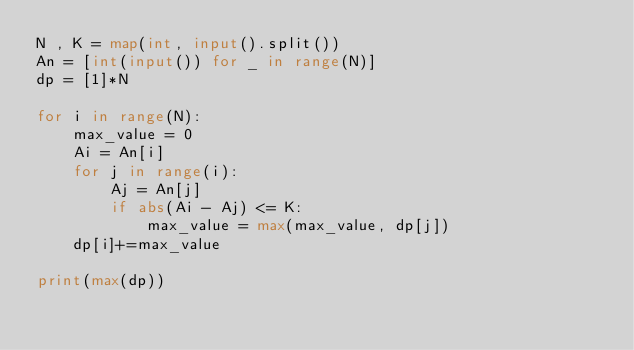Convert code to text. <code><loc_0><loc_0><loc_500><loc_500><_Python_>N , K = map(int, input().split())
An = [int(input()) for _ in range(N)]
dp = [1]*N

for i in range(N):
    max_value = 0
    Ai = An[i]
    for j in range(i):
        Aj = An[j]
        if abs(Ai - Aj) <= K:
            max_value = max(max_value, dp[j])
    dp[i]+=max_value

print(max(dp))
</code> 